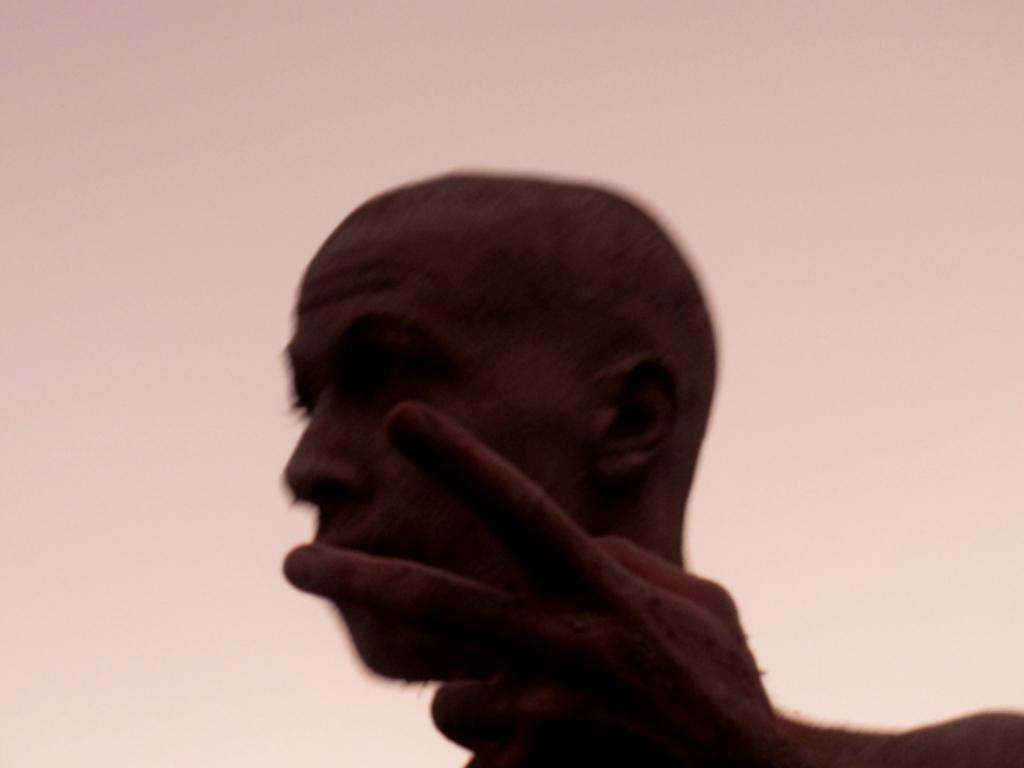What is the main subject of the image? There is a person in the image. Can you describe the background of the image? The background of the image is pink and cream colored. What type of hat is the person wearing in the image? There is no hat visible in the image. How many legs does the can have in the image? There is no can present in the image, so it is not possible to determine how many legs it might have. 